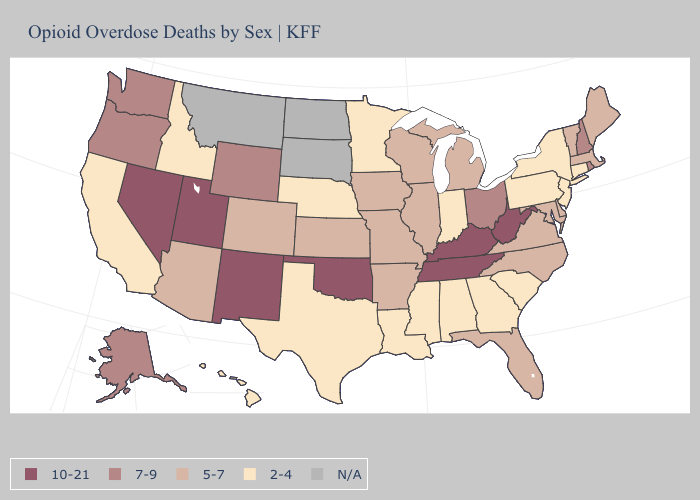How many symbols are there in the legend?
Give a very brief answer. 5. Among the states that border Connecticut , does Massachusetts have the highest value?
Answer briefly. No. Among the states that border Mississippi , which have the lowest value?
Short answer required. Alabama, Louisiana. Is the legend a continuous bar?
Concise answer only. No. Does the map have missing data?
Concise answer only. Yes. Does Oregon have the highest value in the USA?
Give a very brief answer. No. How many symbols are there in the legend?
Short answer required. 5. Does Georgia have the lowest value in the USA?
Concise answer only. Yes. What is the value of Virginia?
Write a very short answer. 5-7. Which states hav the highest value in the Northeast?
Answer briefly. New Hampshire, Rhode Island. What is the value of Oregon?
Answer briefly. 7-9. What is the value of Rhode Island?
Quick response, please. 7-9. Which states have the highest value in the USA?
Concise answer only. Kentucky, Nevada, New Mexico, Oklahoma, Tennessee, Utah, West Virginia. 